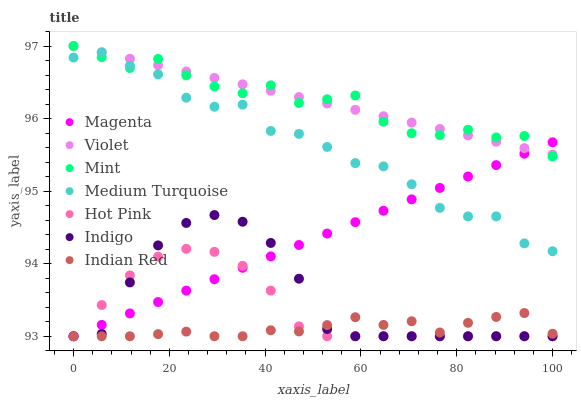Does Indian Red have the minimum area under the curve?
Answer yes or no. Yes. Does Violet have the maximum area under the curve?
Answer yes or no. Yes. Does Hot Pink have the minimum area under the curve?
Answer yes or no. No. Does Hot Pink have the maximum area under the curve?
Answer yes or no. No. Is Violet the smoothest?
Answer yes or no. Yes. Is Medium Turquoise the roughest?
Answer yes or no. Yes. Is Indian Red the smoothest?
Answer yes or no. No. Is Indian Red the roughest?
Answer yes or no. No. Does Indigo have the lowest value?
Answer yes or no. Yes. Does Medium Turquoise have the lowest value?
Answer yes or no. No. Does Mint have the highest value?
Answer yes or no. Yes. Does Hot Pink have the highest value?
Answer yes or no. No. Is Indigo less than Violet?
Answer yes or no. Yes. Is Violet greater than Hot Pink?
Answer yes or no. Yes. Does Hot Pink intersect Indigo?
Answer yes or no. Yes. Is Hot Pink less than Indigo?
Answer yes or no. No. Is Hot Pink greater than Indigo?
Answer yes or no. No. Does Indigo intersect Violet?
Answer yes or no. No. 